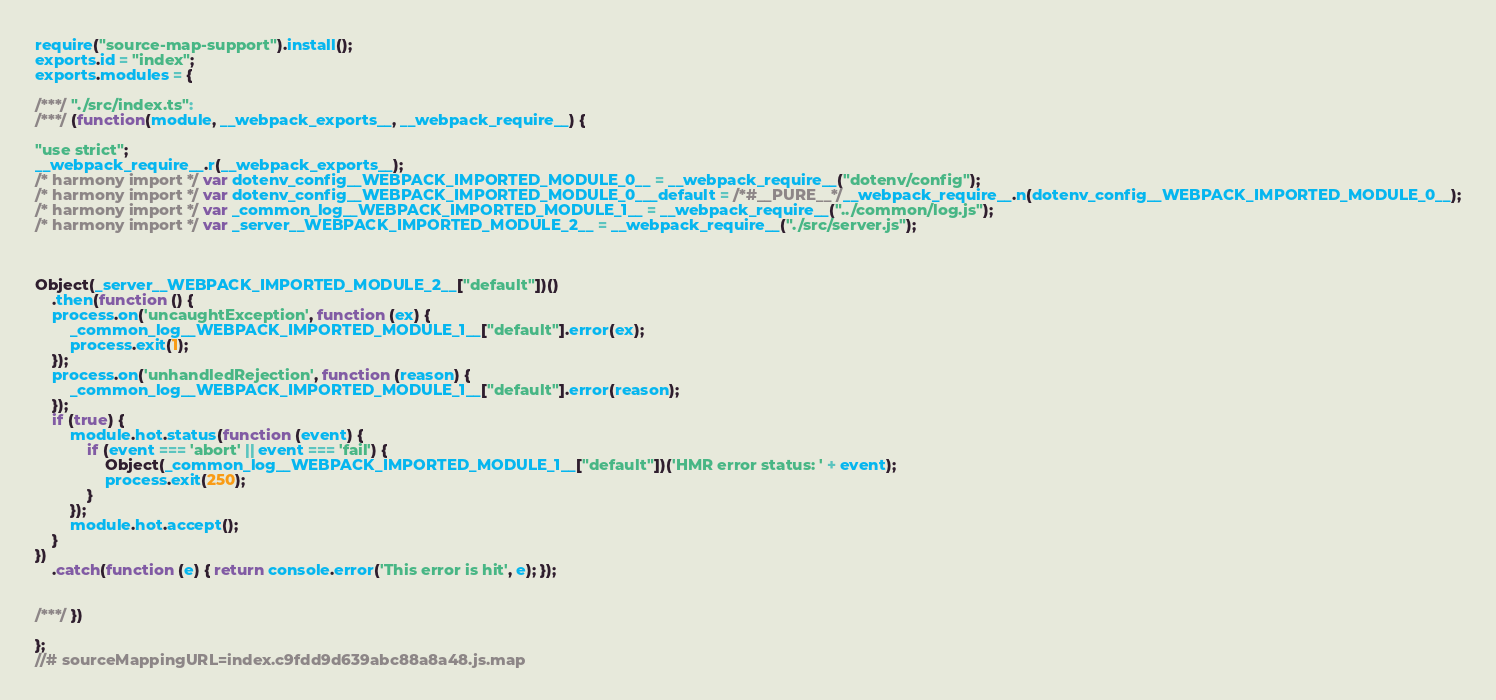<code> <loc_0><loc_0><loc_500><loc_500><_JavaScript_>require("source-map-support").install();
exports.id = "index";
exports.modules = {

/***/ "./src/index.ts":
/***/ (function(module, __webpack_exports__, __webpack_require__) {

"use strict";
__webpack_require__.r(__webpack_exports__);
/* harmony import */ var dotenv_config__WEBPACK_IMPORTED_MODULE_0__ = __webpack_require__("dotenv/config");
/* harmony import */ var dotenv_config__WEBPACK_IMPORTED_MODULE_0___default = /*#__PURE__*/__webpack_require__.n(dotenv_config__WEBPACK_IMPORTED_MODULE_0__);
/* harmony import */ var _common_log__WEBPACK_IMPORTED_MODULE_1__ = __webpack_require__("../common/log.js");
/* harmony import */ var _server__WEBPACK_IMPORTED_MODULE_2__ = __webpack_require__("./src/server.js");



Object(_server__WEBPACK_IMPORTED_MODULE_2__["default"])()
    .then(function () {
    process.on('uncaughtException', function (ex) {
        _common_log__WEBPACK_IMPORTED_MODULE_1__["default"].error(ex);
        process.exit(1);
    });
    process.on('unhandledRejection', function (reason) {
        _common_log__WEBPACK_IMPORTED_MODULE_1__["default"].error(reason);
    });
    if (true) {
        module.hot.status(function (event) {
            if (event === 'abort' || event === 'fail') {
                Object(_common_log__WEBPACK_IMPORTED_MODULE_1__["default"])('HMR error status: ' + event);
                process.exit(250);
            }
        });
        module.hot.accept();
    }
})
    .catch(function (e) { return console.error('This error is hit', e); });


/***/ })

};
//# sourceMappingURL=index.c9fdd9d639abc88a8a48.js.map</code> 